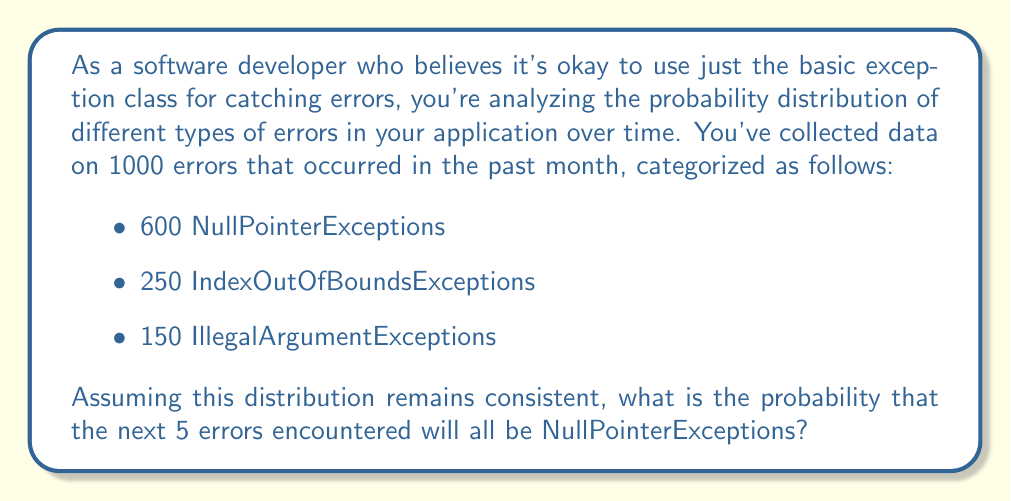Provide a solution to this math problem. To solve this problem, we need to use the concept of independent events and multiply the individual probabilities.

1. First, let's calculate the probability of encountering a NullPointerException:
   $P(\text{NullPointerException}) = \frac{600}{1000} = 0.6$

2. Now, we need to calculate the probability of encountering a NullPointerException 5 times in a row. Since the events are independent (assuming the distribution remains consistent), we multiply the individual probabilities:

   $P(\text{5 NullPointerExceptions in a row}) = 0.6 \times 0.6 \times 0.6 \times 0.6 \times 0.6 = 0.6^5$

3. Let's calculate this:
   $0.6^5 = 0.07776$

Therefore, the probability of encountering 5 NullPointerExceptions in a row is approximately 0.07776 or 7.776%.

This result shows that even though NullPointerExceptions are the most common error type in your application, the probability of encountering five in a row is relatively low. This highlights the importance of handling different types of exceptions, rather than relying solely on a basic exception class.
Answer: The probability that the next 5 errors encountered will all be NullPointerExceptions is approximately 0.07776 or 7.776%. 